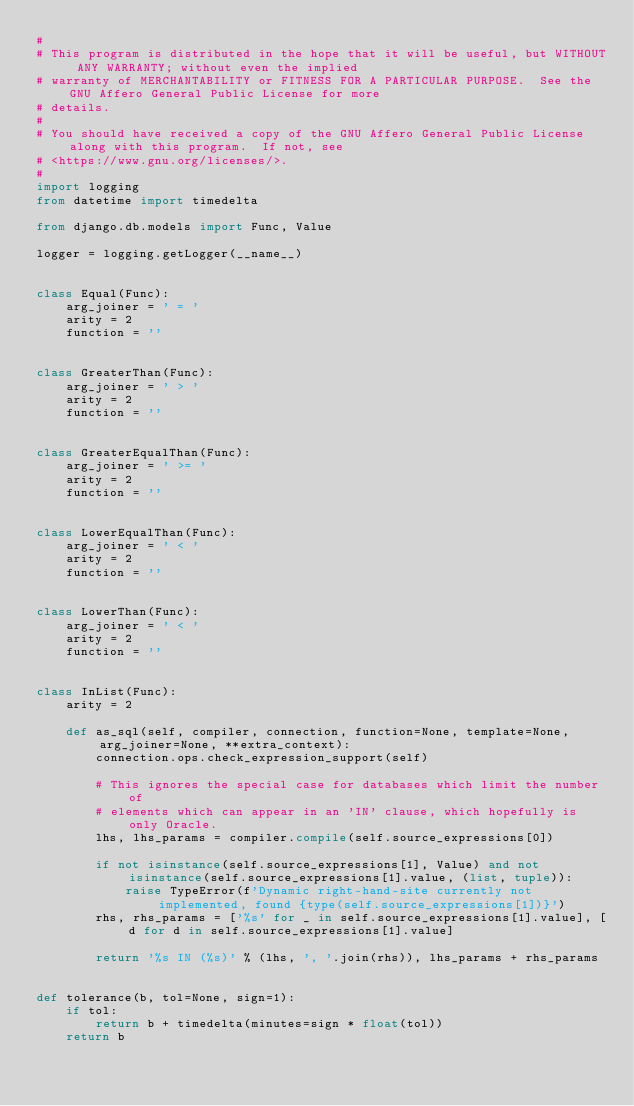<code> <loc_0><loc_0><loc_500><loc_500><_Python_>#
# This program is distributed in the hope that it will be useful, but WITHOUT ANY WARRANTY; without even the implied
# warranty of MERCHANTABILITY or FITNESS FOR A PARTICULAR PURPOSE.  See the GNU Affero General Public License for more
# details.
#
# You should have received a copy of the GNU Affero General Public License along with this program.  If not, see
# <https://www.gnu.org/licenses/>.
#
import logging
from datetime import timedelta

from django.db.models import Func, Value

logger = logging.getLogger(__name__)


class Equal(Func):
    arg_joiner = ' = '
    arity = 2
    function = ''


class GreaterThan(Func):
    arg_joiner = ' > '
    arity = 2
    function = ''


class GreaterEqualThan(Func):
    arg_joiner = ' >= '
    arity = 2
    function = ''


class LowerEqualThan(Func):
    arg_joiner = ' < '
    arity = 2
    function = ''


class LowerThan(Func):
    arg_joiner = ' < '
    arity = 2
    function = ''


class InList(Func):
    arity = 2

    def as_sql(self, compiler, connection, function=None, template=None, arg_joiner=None, **extra_context):
        connection.ops.check_expression_support(self)

        # This ignores the special case for databases which limit the number of
        # elements which can appear in an 'IN' clause, which hopefully is only Oracle.
        lhs, lhs_params = compiler.compile(self.source_expressions[0])

        if not isinstance(self.source_expressions[1], Value) and not isinstance(self.source_expressions[1].value, (list, tuple)):
            raise TypeError(f'Dynamic right-hand-site currently not implemented, found {type(self.source_expressions[1])}')
        rhs, rhs_params = ['%s' for _ in self.source_expressions[1].value], [d for d in self.source_expressions[1].value]

        return '%s IN (%s)' % (lhs, ', '.join(rhs)), lhs_params + rhs_params


def tolerance(b, tol=None, sign=1):
    if tol:
        return b + timedelta(minutes=sign * float(tol))
    return b
</code> 